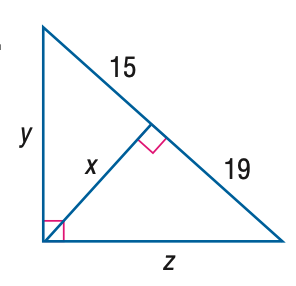Answer the mathemtical geometry problem and directly provide the correct option letter.
Question: Find z.
Choices: A: \sqrt { 285 } B: \sqrt { 646 } C: 2 \sqrt { 285 } D: 2 \sqrt { 646 } B 